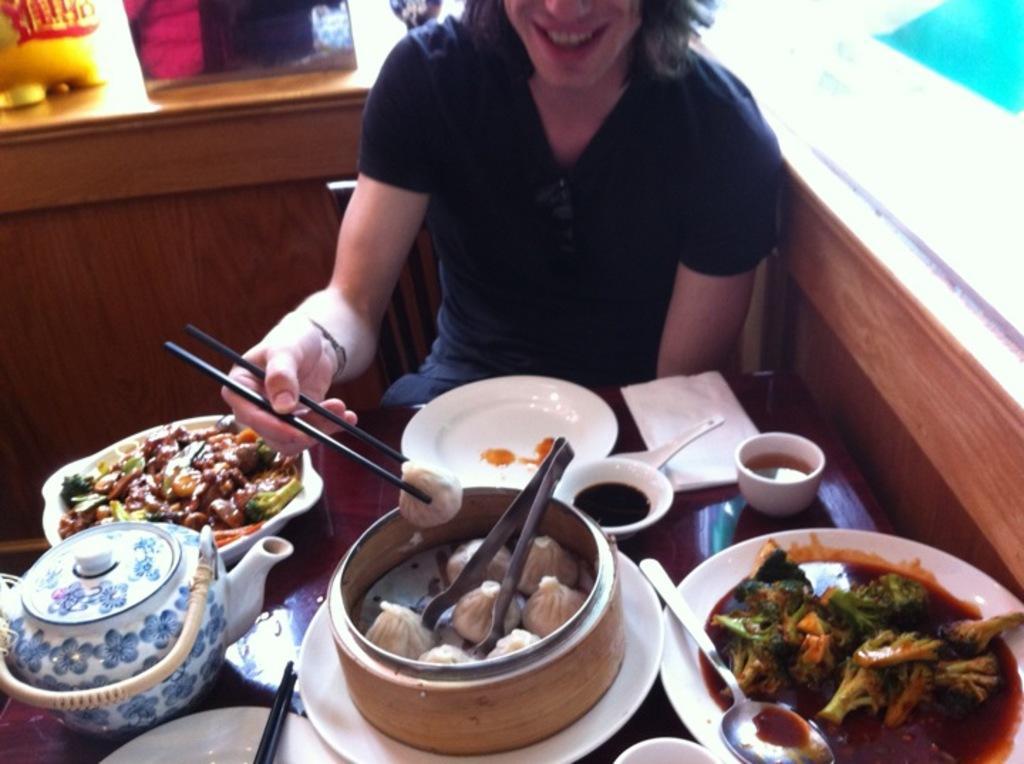Describe this image in one or two sentences. In this picture we can see a person is sitting and holding the chopsticks. In front of the person there is a table and on the table there are plates, bowls, cups, tongs, spoons, chopsticks, jar and some food items. Behind the person it is looking like a platform and on the platform there are some items. 